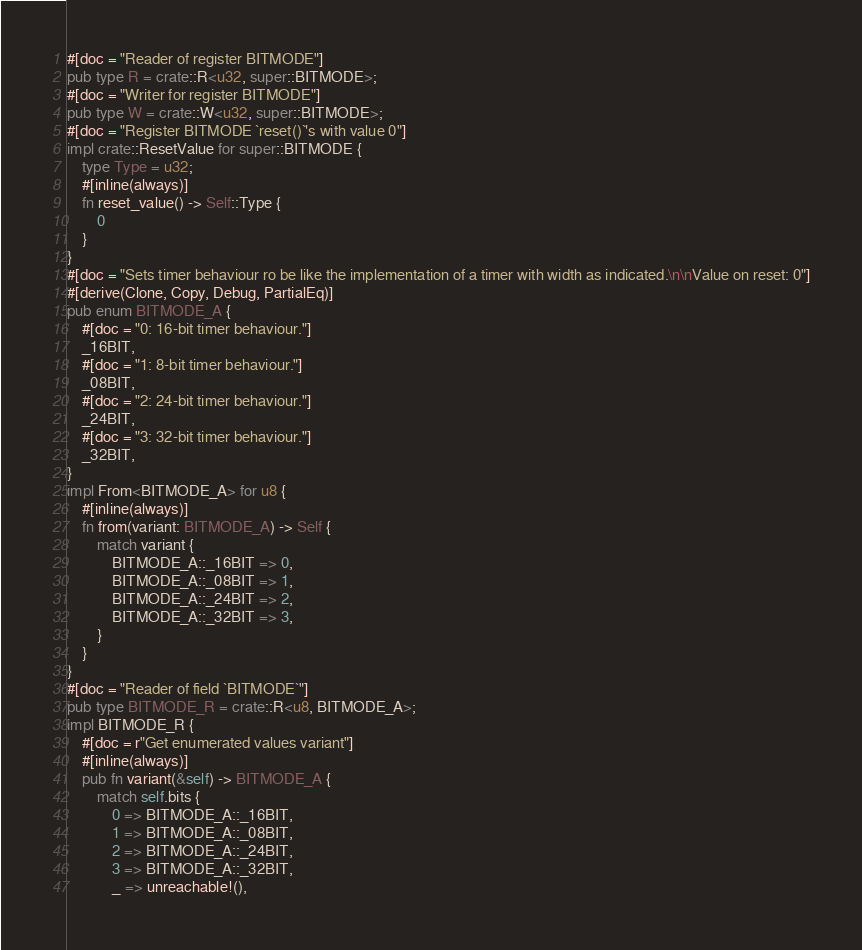<code> <loc_0><loc_0><loc_500><loc_500><_Rust_>#[doc = "Reader of register BITMODE"]
pub type R = crate::R<u32, super::BITMODE>;
#[doc = "Writer for register BITMODE"]
pub type W = crate::W<u32, super::BITMODE>;
#[doc = "Register BITMODE `reset()`'s with value 0"]
impl crate::ResetValue for super::BITMODE {
    type Type = u32;
    #[inline(always)]
    fn reset_value() -> Self::Type {
        0
    }
}
#[doc = "Sets timer behaviour ro be like the implementation of a timer with width as indicated.\n\nValue on reset: 0"]
#[derive(Clone, Copy, Debug, PartialEq)]
pub enum BITMODE_A {
    #[doc = "0: 16-bit timer behaviour."]
    _16BIT,
    #[doc = "1: 8-bit timer behaviour."]
    _08BIT,
    #[doc = "2: 24-bit timer behaviour."]
    _24BIT,
    #[doc = "3: 32-bit timer behaviour."]
    _32BIT,
}
impl From<BITMODE_A> for u8 {
    #[inline(always)]
    fn from(variant: BITMODE_A) -> Self {
        match variant {
            BITMODE_A::_16BIT => 0,
            BITMODE_A::_08BIT => 1,
            BITMODE_A::_24BIT => 2,
            BITMODE_A::_32BIT => 3,
        }
    }
}
#[doc = "Reader of field `BITMODE`"]
pub type BITMODE_R = crate::R<u8, BITMODE_A>;
impl BITMODE_R {
    #[doc = r"Get enumerated values variant"]
    #[inline(always)]
    pub fn variant(&self) -> BITMODE_A {
        match self.bits {
            0 => BITMODE_A::_16BIT,
            1 => BITMODE_A::_08BIT,
            2 => BITMODE_A::_24BIT,
            3 => BITMODE_A::_32BIT,
            _ => unreachable!(),</code> 